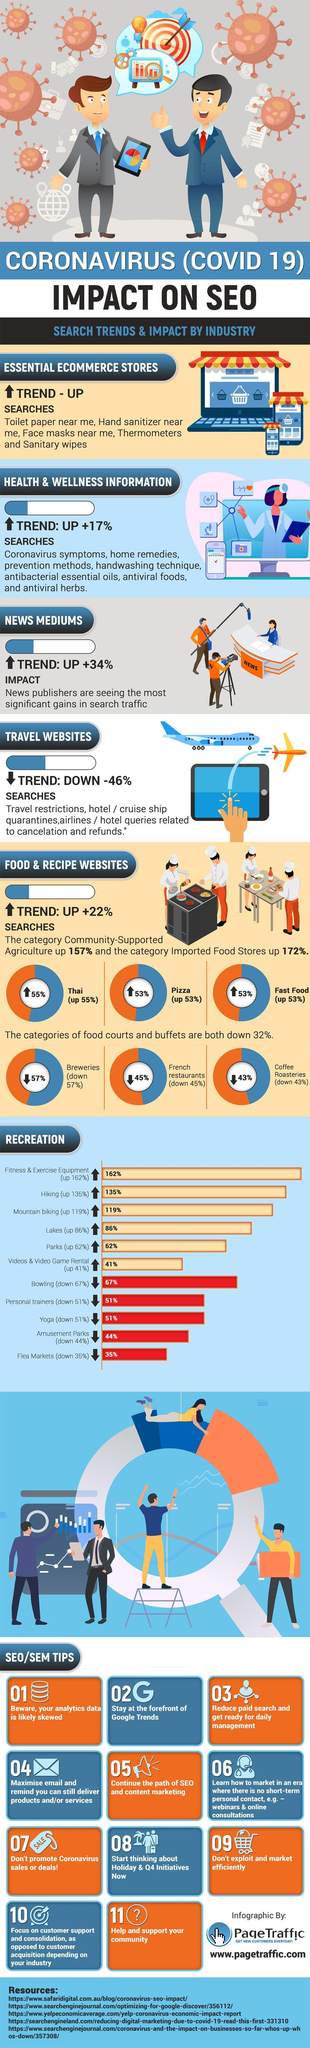What percentage of down in Thai foods?
Answer the question with a short phrase. 45% What percentage of down in Pizza? 47% What percentage up in Breweries? 43% What percentage up in Coffee Roasteries? 57% 